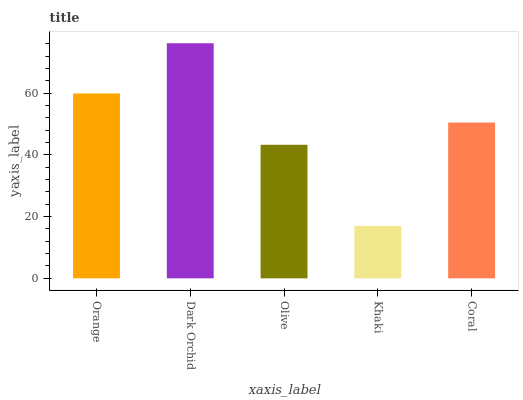Is Khaki the minimum?
Answer yes or no. Yes. Is Dark Orchid the maximum?
Answer yes or no. Yes. Is Olive the minimum?
Answer yes or no. No. Is Olive the maximum?
Answer yes or no. No. Is Dark Orchid greater than Olive?
Answer yes or no. Yes. Is Olive less than Dark Orchid?
Answer yes or no. Yes. Is Olive greater than Dark Orchid?
Answer yes or no. No. Is Dark Orchid less than Olive?
Answer yes or no. No. Is Coral the high median?
Answer yes or no. Yes. Is Coral the low median?
Answer yes or no. Yes. Is Orange the high median?
Answer yes or no. No. Is Olive the low median?
Answer yes or no. No. 